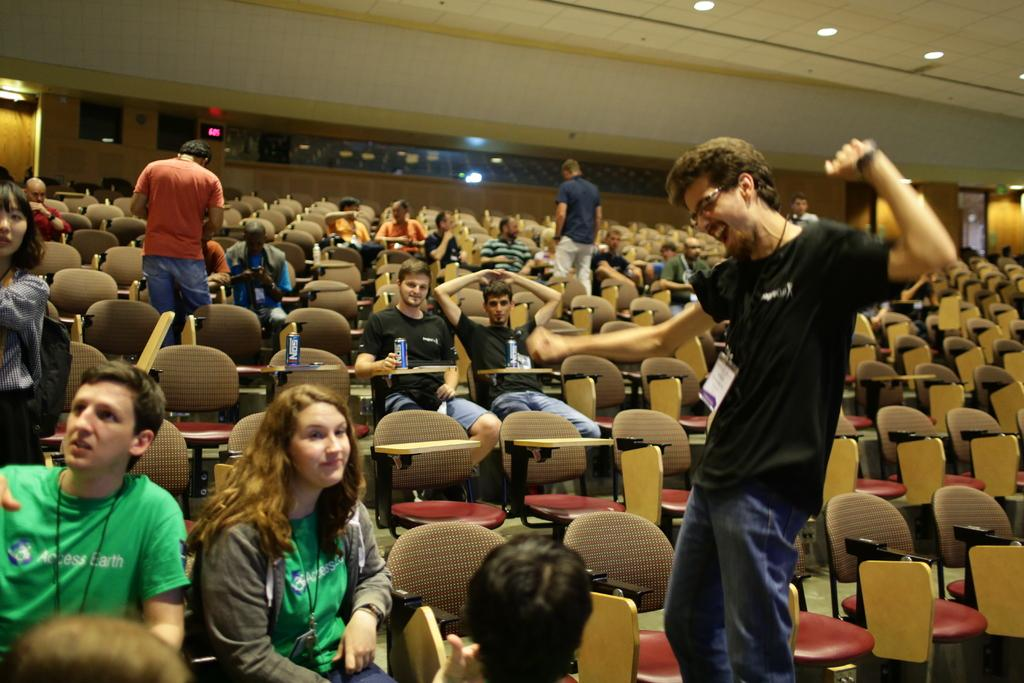What is the main subject of the image? The main subject of the image is a group of people. Can you describe the positions of the people in the group? Some people in the group are sitting in chairs, while others are standing. How many people are sitting in chairs? The number of people sitting in chairs is not specified in the facts provided. What type of watch is the person in the image wearing? There is no mention of a watch or any accessories in the image. 